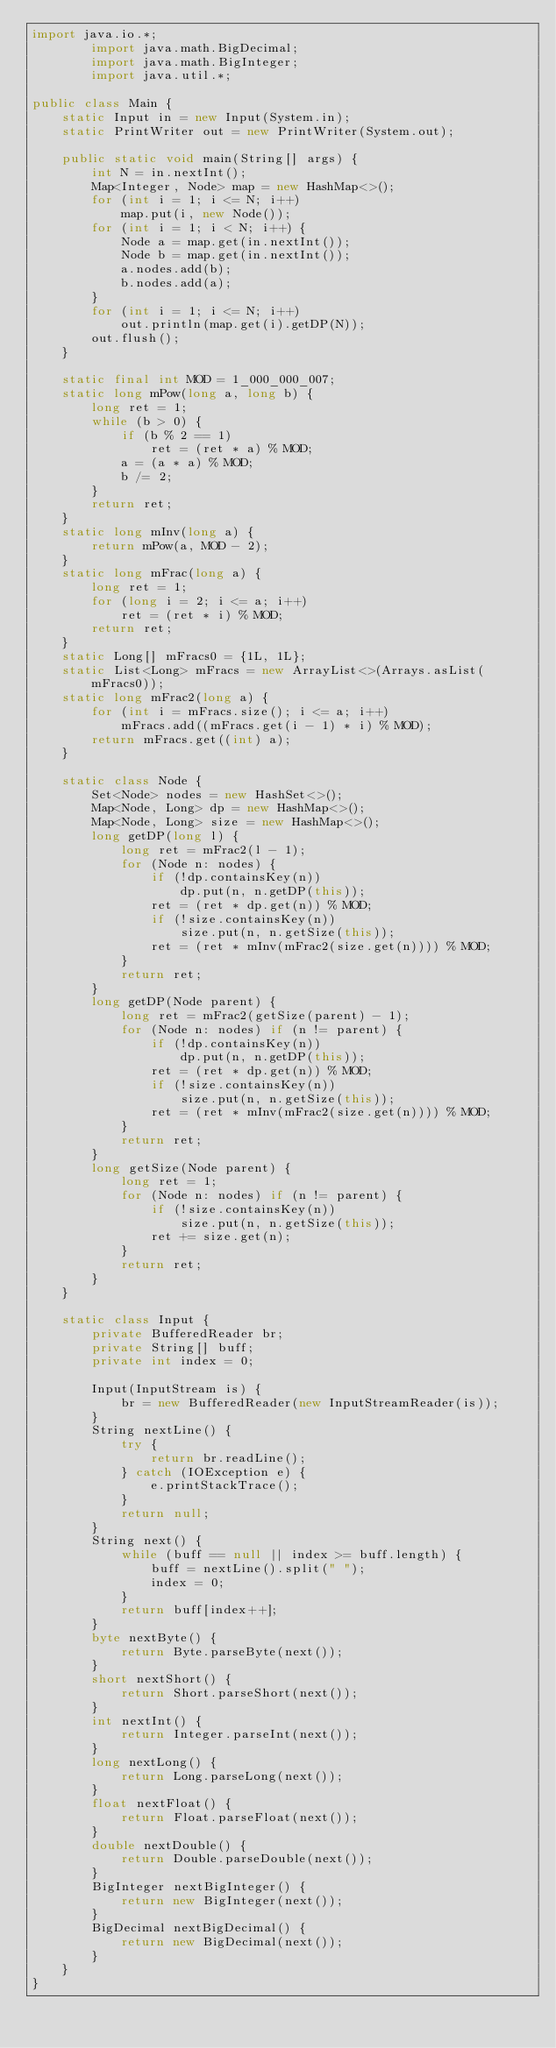Convert code to text. <code><loc_0><loc_0><loc_500><loc_500><_Java_>import java.io.*;
        import java.math.BigDecimal;
        import java.math.BigInteger;
        import java.util.*;

public class Main {
    static Input in = new Input(System.in);
    static PrintWriter out = new PrintWriter(System.out);

    public static void main(String[] args) {
        int N = in.nextInt();
        Map<Integer, Node> map = new HashMap<>();
        for (int i = 1; i <= N; i++)
            map.put(i, new Node());
        for (int i = 1; i < N; i++) {
            Node a = map.get(in.nextInt());
            Node b = map.get(in.nextInt());
            a.nodes.add(b);
            b.nodes.add(a);
        }
        for (int i = 1; i <= N; i++)
            out.println(map.get(i).getDP(N));
        out.flush();
    }

    static final int MOD = 1_000_000_007;
    static long mPow(long a, long b) {
        long ret = 1;
        while (b > 0) {
            if (b % 2 == 1)
                ret = (ret * a) % MOD;
            a = (a * a) % MOD;
            b /= 2;
        }
        return ret;
    }
    static long mInv(long a) {
        return mPow(a, MOD - 2);
    }
    static long mFrac(long a) {
        long ret = 1;
        for (long i = 2; i <= a; i++)
            ret = (ret * i) % MOD;
        return ret;
    }
    static Long[] mFracs0 = {1L, 1L};
    static List<Long> mFracs = new ArrayList<>(Arrays.asList(mFracs0));
    static long mFrac2(long a) {
        for (int i = mFracs.size(); i <= a; i++)
            mFracs.add((mFracs.get(i - 1) * i) % MOD);
        return mFracs.get((int) a);
    }

    static class Node {
        Set<Node> nodes = new HashSet<>();
        Map<Node, Long> dp = new HashMap<>();
        Map<Node, Long> size = new HashMap<>();
        long getDP(long l) {
            long ret = mFrac2(l - 1);
            for (Node n: nodes) {
                if (!dp.containsKey(n))
                    dp.put(n, n.getDP(this));
                ret = (ret * dp.get(n)) % MOD;
                if (!size.containsKey(n))
                    size.put(n, n.getSize(this));
                ret = (ret * mInv(mFrac2(size.get(n)))) % MOD;
            }
            return ret;
        }
        long getDP(Node parent) {
            long ret = mFrac2(getSize(parent) - 1);
            for (Node n: nodes) if (n != parent) {
                if (!dp.containsKey(n))
                    dp.put(n, n.getDP(this));
                ret = (ret * dp.get(n)) % MOD;
                if (!size.containsKey(n))
                    size.put(n, n.getSize(this));
                ret = (ret * mInv(mFrac2(size.get(n)))) % MOD;
            }
            return ret;
        }
        long getSize(Node parent) {
            long ret = 1;
            for (Node n: nodes) if (n != parent) {
                if (!size.containsKey(n))
                    size.put(n, n.getSize(this));
                ret += size.get(n);
            }
            return ret;
        }
    }

    static class Input {
        private BufferedReader br;
        private String[] buff;
        private int index = 0;

        Input(InputStream is) {
            br = new BufferedReader(new InputStreamReader(is));
        }
        String nextLine() {
            try {
                return br.readLine();
            } catch (IOException e) {
                e.printStackTrace();
            }
            return null;
        }
        String next() {
            while (buff == null || index >= buff.length) {
                buff = nextLine().split(" ");
                index = 0;
            }
            return buff[index++];
        }
        byte nextByte() {
            return Byte.parseByte(next());
        }
        short nextShort() {
            return Short.parseShort(next());
        }
        int nextInt() {
            return Integer.parseInt(next());
        }
        long nextLong() {
            return Long.parseLong(next());
        }
        float nextFloat() {
            return Float.parseFloat(next());
        }
        double nextDouble() {
            return Double.parseDouble(next());
        }
        BigInteger nextBigInteger() {
            return new BigInteger(next());
        }
        BigDecimal nextBigDecimal() {
            return new BigDecimal(next());
        }
    }
}</code> 